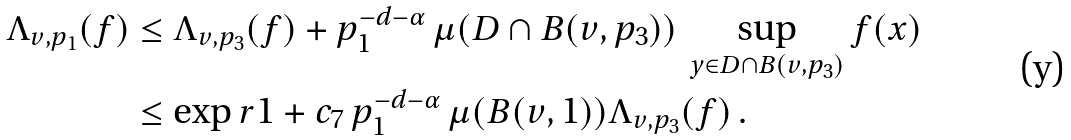<formula> <loc_0><loc_0><loc_500><loc_500>\Lambda _ { v , p _ { 1 } } ( f ) & \leq \Lambda _ { v , p _ { 3 } } ( f ) + p _ { 1 } ^ { - d - \alpha } \, \mu ( D \cap B ( v , p _ { 3 } ) ) \, \sup _ { y \in D \cap B ( v , p _ { 3 } ) } f ( x ) \\ & \leq \exp r { 1 + c _ { 7 } \, p _ { 1 } ^ { - d - \alpha } \, \mu ( B ( v , 1 ) ) } \Lambda _ { v , p _ { 3 } } ( f ) \, .</formula> 